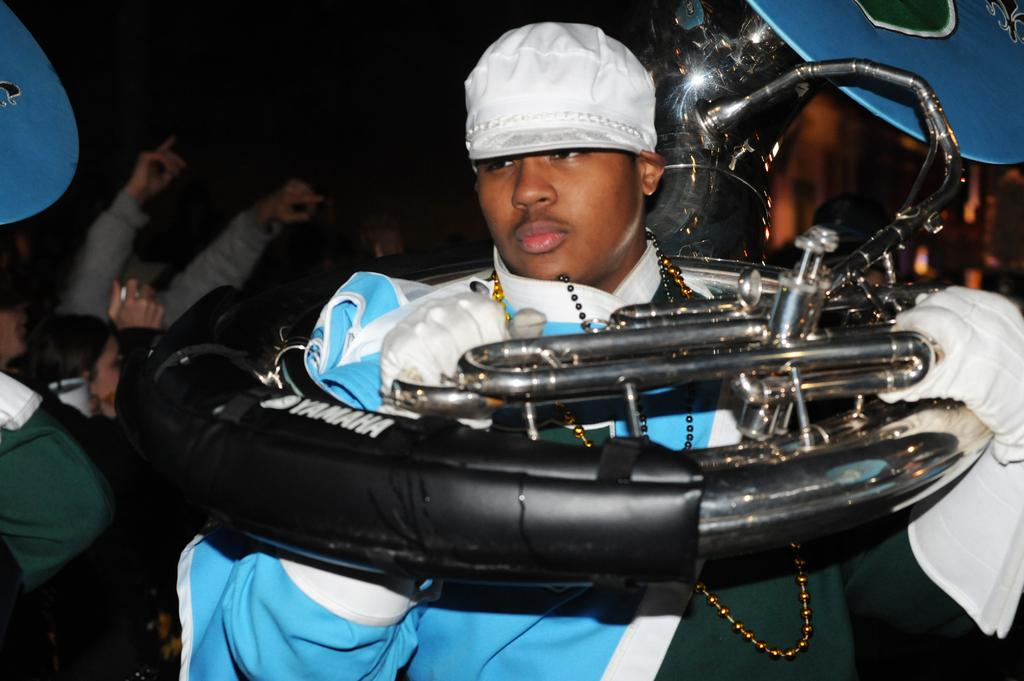Who is present in the image? There is a person in the image. What is the person wearing? The person is wearing a blue dress. What is the person holding in the image? The person is holding an object that is black in color. Can you describe the surroundings of the person? There are other persons visible in the background of the image. What type of vein is visible on the person's forehead in the image? There is no visible vein on the person's forehead in the image. 